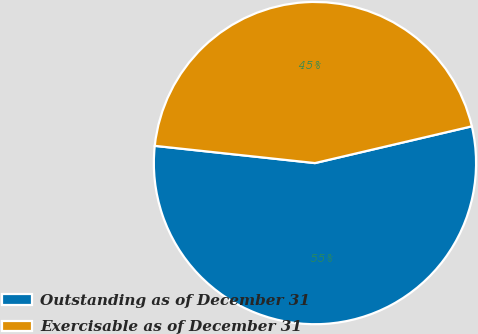Convert chart. <chart><loc_0><loc_0><loc_500><loc_500><pie_chart><fcel>Outstanding as of December 31<fcel>Exercisable as of December 31<nl><fcel>55.37%<fcel>44.63%<nl></chart> 